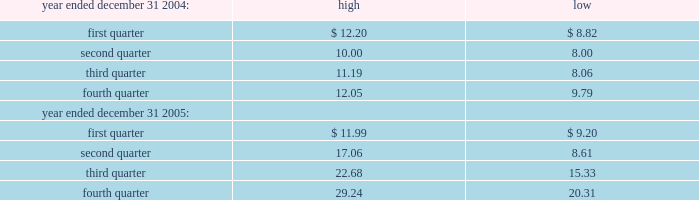Part ii item 5 .
Market for registrant's common equity , related stockholder matters and issuer purchases of equity securities market information our common stock is traded on the nasdaq national market under the symbol "vrtx." the table sets forth for the periods indicated the high and low sale prices per share of our common stock as reported by nasdaq : as of march 14 , 2006 , there were 1312 holders of record of our common stock ( approximately 20200 beneficial holders ) .
Dividends we have never declared or paid any cash dividends on our common stock , and we currently expect that future earnings , if any , will be retained for use in our business .
Issuer repurchases of equity securities we did not repurchase any equity securities of the company during the quarter ended december 31 , 2005 .
Unregistered sales of equity securities in december 2005 , we issued an additional 781000 shares of our common stock in connection with exchanges with certain existing holders of 2011 notes .
The exchanges were exempt from registration under the securities act of 1933 , as amended , under section 3 ( a ) ( 9 ) thereof , as exchanges by the company of securities with its existing holders exclusively in transactions in which no commission or other remuneration was paid. .

What was the average quarterly highs in 2004? 
Computations: ((((11.19 + (12.20 + 10.00)) + 12.05) + 4) / 2)
Answer: 24.72. 